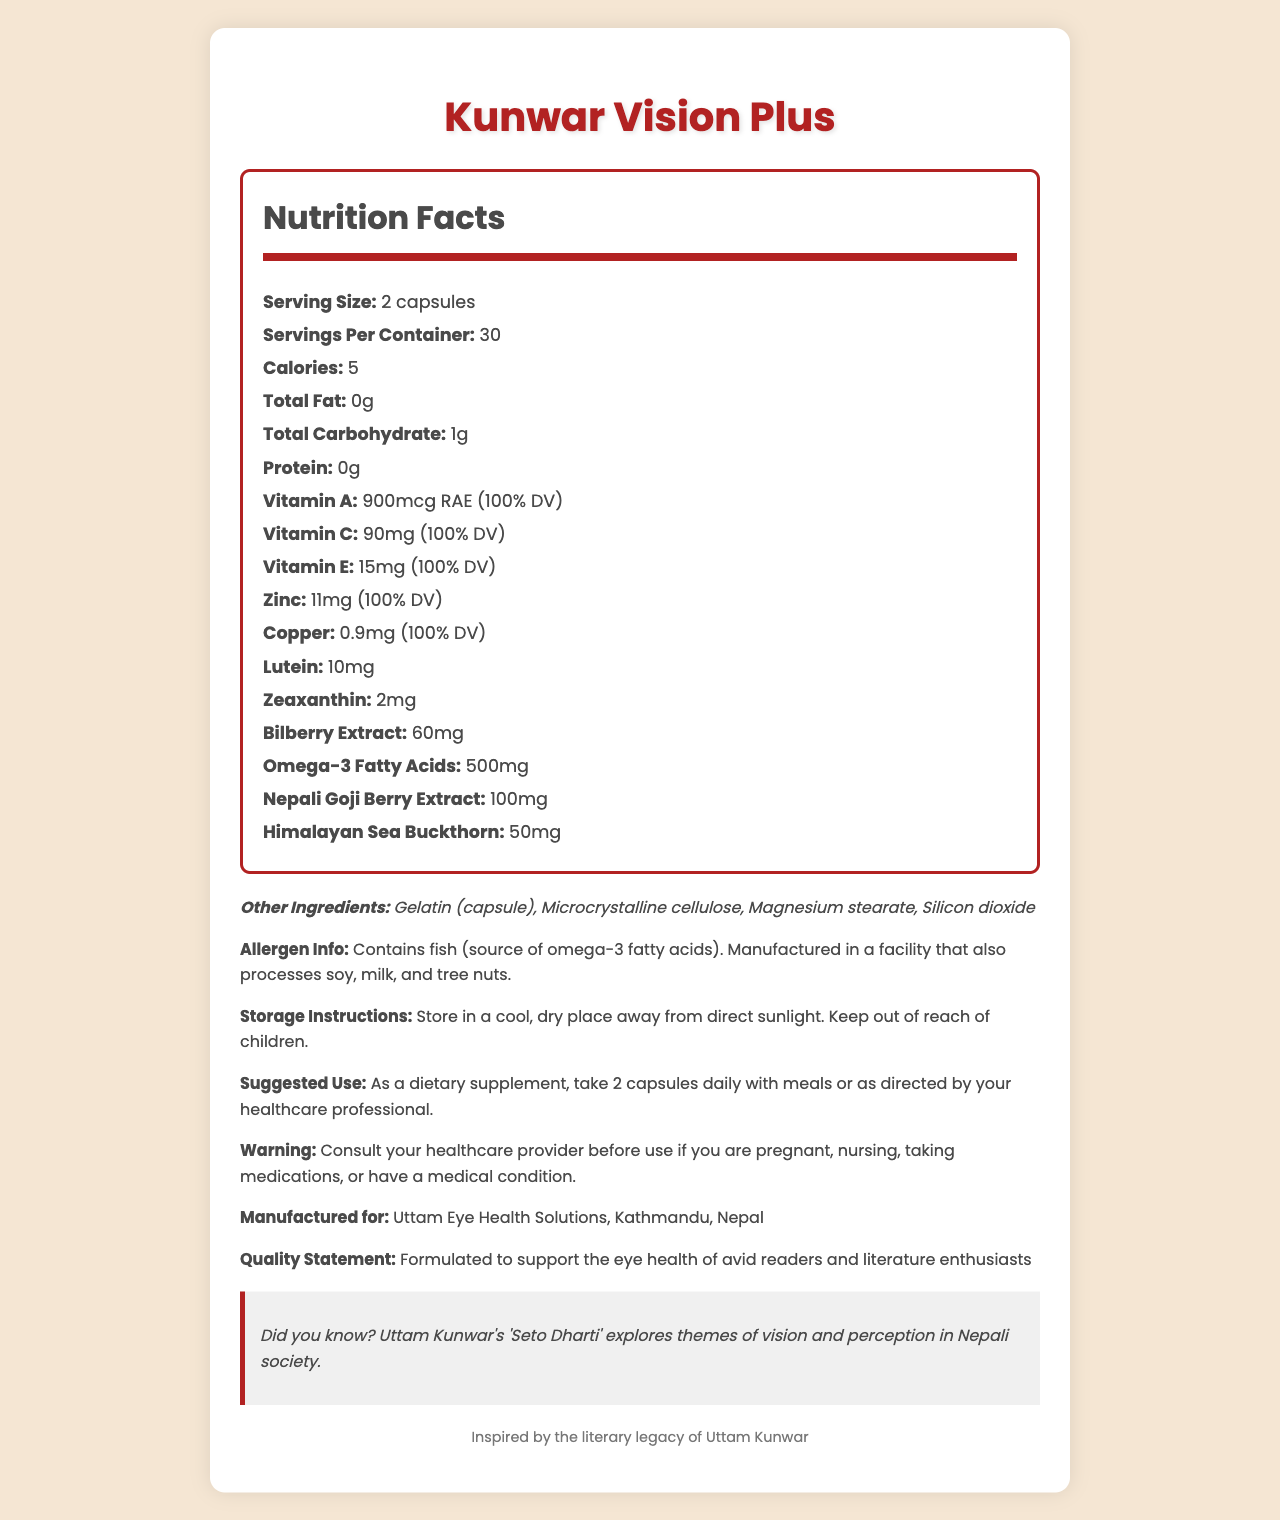what is the serving size for Kunwar Vision Plus? The serving size is clearly mentioned as "2 capsules" in the Nutrition Facts section.
Answer: 2 capsules how many calories are in each serving? The document states that each serving contains 5 calories.
Answer: 5 what percentage of the daily value for Vitamin A does Kunwar Vision Plus provide? The document lists Vitamin A as "900mcg RAE (100% DV)".
Answer: 100% DV which ingredient in Kunwar Vision Plus is a potential allergen? The allergen information section mentions that the product contains fish as a source of omega-3 fatty acids.
Answer: Fish (source of omega-3 fatty acids) who is Kunwar Vision Plus manufactured for? The document states that the product is manufactured for Uttam Eye Health Solutions, Kathmandu, Nepal.
Answer: Uttam Eye Health Solutions, Kathmandu, Nepal what should one do before using Kunwar Vision Plus if they are pregnant or nursing? The warning section specifically advises consulting a healthcare provider before use if one is pregnant or nursing.
Answer: Consult your healthcare provider what is the suggested use for Kunwar Vision Plus? The suggested use is outlined in the corresponding section.
Answer: As a dietary supplement, take 2 capsules daily with meals or as directed by your healthcare professional true or false: Kunwar Vision Plus is completely free of protein. The Nutrition Facts section lists protein as "0g", indicating that the product is free of protein.
Answer: True which of the following vitamins are included in Kunwar Vision Plus? A. Vitamin A B. Vitamin C C. Vitamin E D. All of the above The document lists Vitamin A, Vitamin C, and Vitamin E as ingredients.
Answer: D what type of facility manufactures Kunwar Vision Plus? A. A fish-only processing facility B. A facility that processes soy, milk, and tree nuts C. A facility with no allergens D. A dairy-free facility The allergen information section mentions that the product is manufactured in a facility that also processes soy, milk, and tree nuts.
Answer: B what is the main intent of Kunwar Vision Plus as described in the document? The quality statement states that the product is formulated to support the eye health of avid readers and literature enthusiasts.
Answer: To support the eye health of avid readers and literature enthusiasts what does the fact box say about Uttam Kunwar's work? The fact box gives this specific information about Uttam Kunwar's work.
Answer: 'Seto Dharti' explores themes of vision and perception in Nepali society what is the total amount of lutein and zeaxanthin in each serving? The Nutrition Facts section lists 10mg lutein and 2mg zeaxanthin, summing up to 12mg in total.
Answer: 12mg describe the entire document or the main idea of the document. The document provides comprehensive information about the Kunwar Vision Plus supplement, highlighting its intended use, nutritional content, and other essential details to inform potential users.
Answer: The document is a detailed Nutrition Facts label for Kunwar Vision Plus, a dietary supplement designed to support eye health for avid readers and literature enthusiasts. It includes nutritional information, serving size, ingredients, allergen warnings, storage and usage instructions, and a quality statement. The document also features a fact about Nepali literature, specifically Uttam Kunwar's 'Seto Dharti'. what is the percentage daily value (% DV) of zinc provided by Kunwar Vision Plus? The document lists zinc as "11mg (100% DV)".
Answer: 100% DV how many servings are in one container of Kunwar Vision Plus? The Nutrition Facts section states that there are 30 servings per container.
Answer: 30 does Kunwar Vision Plus contain any other ingredients not listed in the allergen info? The document lists other ingredients like Gelatin (capsule), Microcrystalline cellulose, Magnesium stearate, and Silicon dioxide which are not part of the allergen info.
Answer: Yes who directs the suggested use instructions? Although the product suggests taking 2 capsules daily with meals, it also notes that usage can be as directed by your healthcare professional.
Answer: Your healthcare professional is there enough information to know the price of Kunwar Vision Plus? The document provides comprehensive nutritional and usage information but does not mention the price.
Answer: Not enough information what precaution should one take when storing Kunwar Vision Plus? The storage instructions specify the conditions for keeping the product safe and effective.
Answer: Store in a cool, dry place away from direct sunlight. Keep out of reach of children. 